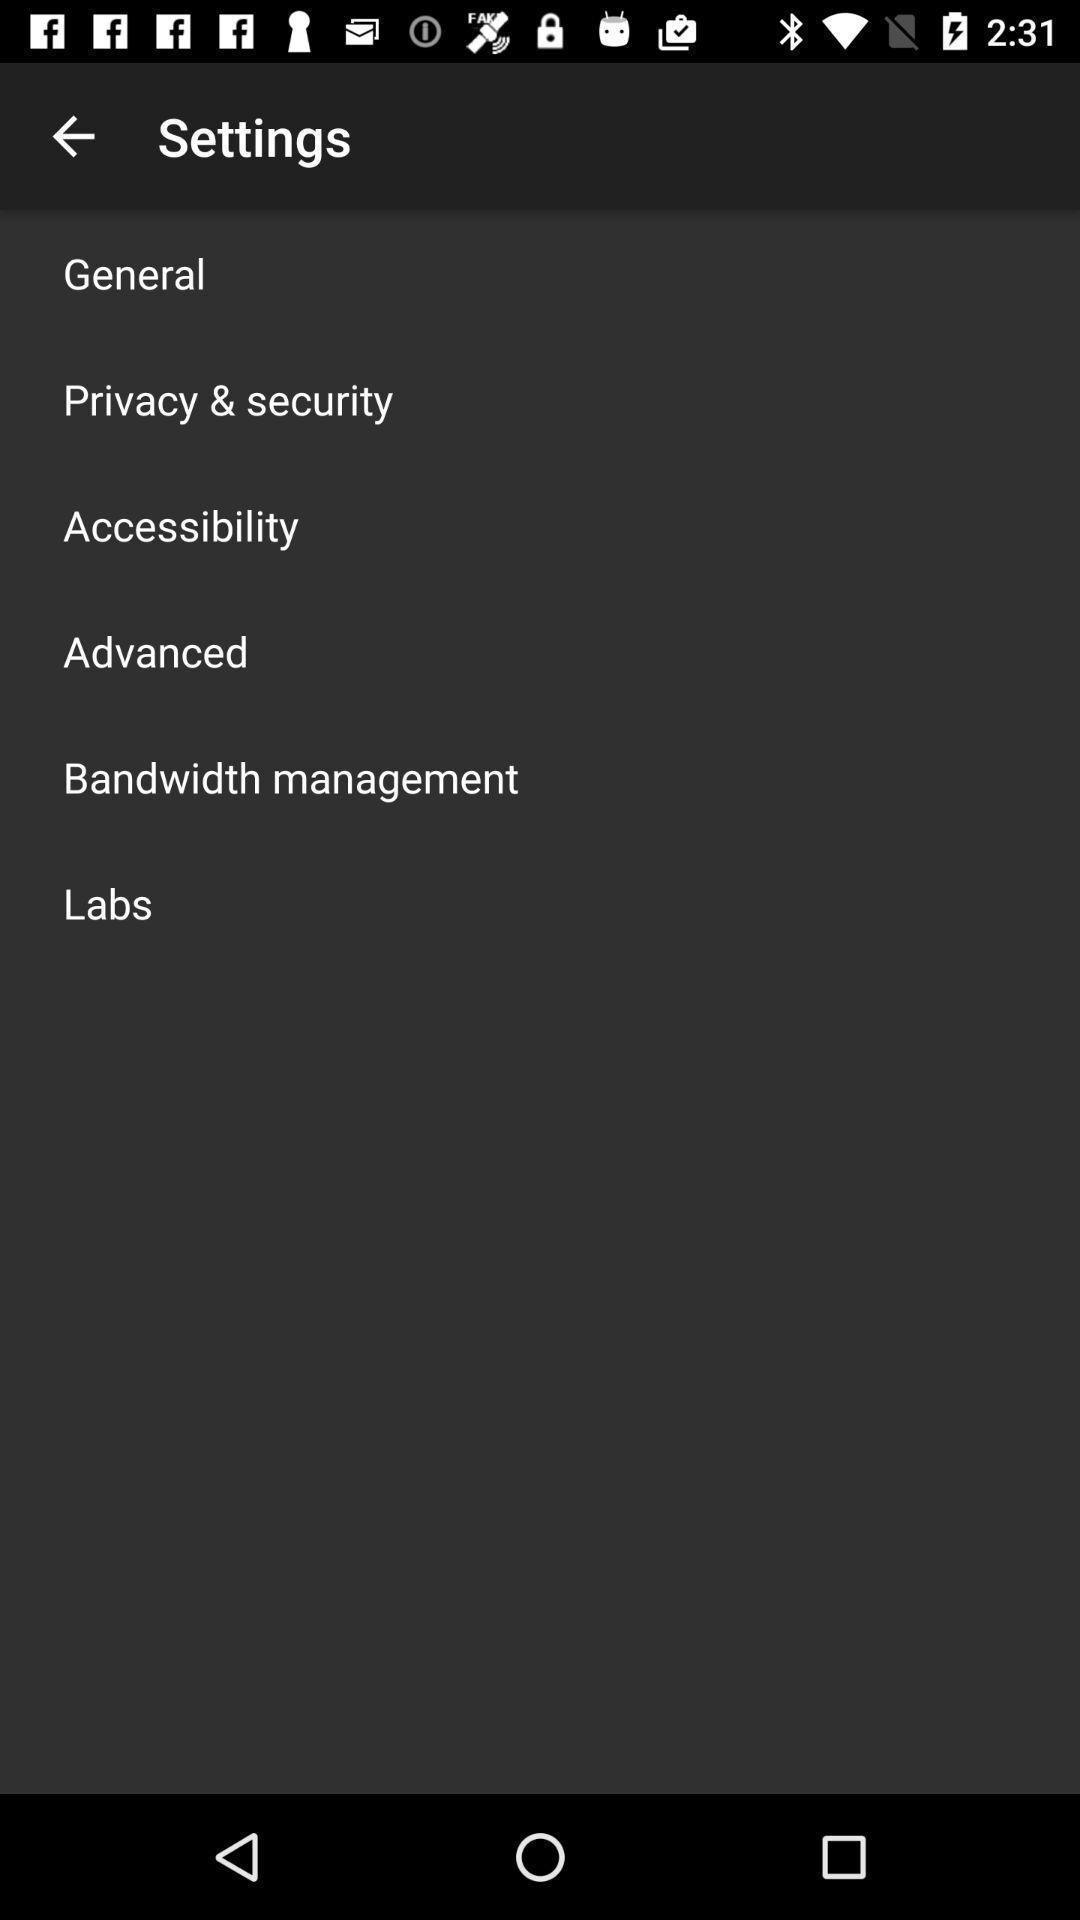Give me a narrative description of this picture. Screen displaying the options in settings tab. 